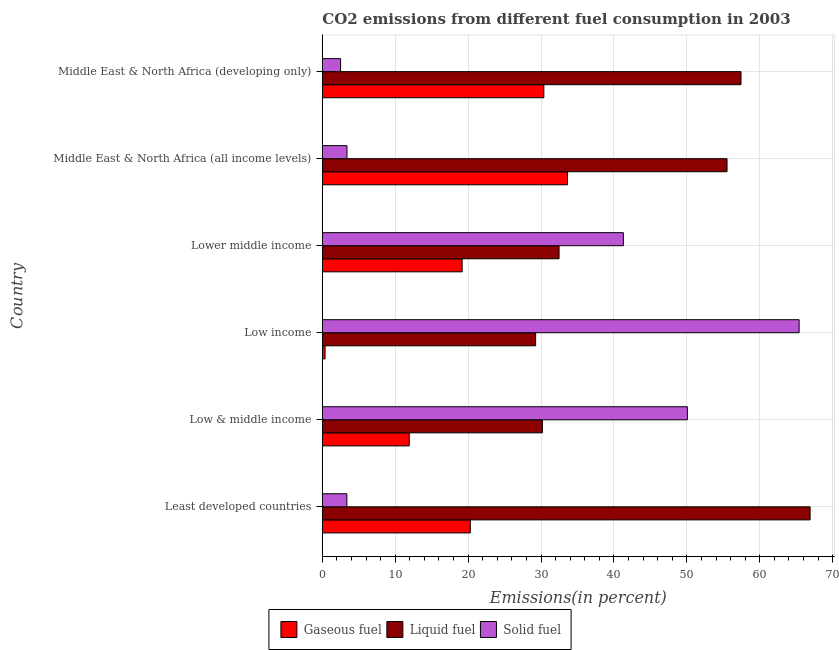How many groups of bars are there?
Make the answer very short. 6. Are the number of bars per tick equal to the number of legend labels?
Provide a succinct answer. Yes. How many bars are there on the 4th tick from the top?
Keep it short and to the point. 3. How many bars are there on the 4th tick from the bottom?
Provide a short and direct response. 3. What is the percentage of solid fuel emission in Middle East & North Africa (developing only)?
Provide a succinct answer. 2.5. Across all countries, what is the maximum percentage of liquid fuel emission?
Your answer should be very brief. 66.91. Across all countries, what is the minimum percentage of gaseous fuel emission?
Your answer should be compact. 0.38. In which country was the percentage of gaseous fuel emission minimum?
Offer a terse response. Low income. What is the total percentage of gaseous fuel emission in the graph?
Your answer should be compact. 115.78. What is the difference between the percentage of gaseous fuel emission in Low income and that in Lower middle income?
Make the answer very short. -18.8. What is the difference between the percentage of liquid fuel emission in Low & middle income and the percentage of gaseous fuel emission in Middle East & North Africa (developing only)?
Your answer should be compact. -0.2. What is the average percentage of gaseous fuel emission per country?
Your response must be concise. 19.3. What is the difference between the percentage of solid fuel emission and percentage of gaseous fuel emission in Middle East & North Africa (developing only)?
Provide a succinct answer. -27.88. In how many countries, is the percentage of liquid fuel emission greater than 58 %?
Provide a short and direct response. 1. What is the ratio of the percentage of liquid fuel emission in Least developed countries to that in Low & middle income?
Your answer should be compact. 2.22. Is the percentage of solid fuel emission in Least developed countries less than that in Middle East & North Africa (all income levels)?
Provide a short and direct response. Yes. Is the difference between the percentage of solid fuel emission in Low & middle income and Lower middle income greater than the difference between the percentage of liquid fuel emission in Low & middle income and Lower middle income?
Give a very brief answer. Yes. What is the difference between the highest and the second highest percentage of solid fuel emission?
Offer a terse response. 15.32. What is the difference between the highest and the lowest percentage of solid fuel emission?
Provide a succinct answer. 62.9. In how many countries, is the percentage of gaseous fuel emission greater than the average percentage of gaseous fuel emission taken over all countries?
Provide a succinct answer. 3. Is the sum of the percentage of gaseous fuel emission in Low & middle income and Low income greater than the maximum percentage of solid fuel emission across all countries?
Your answer should be compact. No. What does the 3rd bar from the top in Middle East & North Africa (all income levels) represents?
Keep it short and to the point. Gaseous fuel. What does the 2nd bar from the bottom in Lower middle income represents?
Offer a very short reply. Liquid fuel. Is it the case that in every country, the sum of the percentage of gaseous fuel emission and percentage of liquid fuel emission is greater than the percentage of solid fuel emission?
Provide a short and direct response. No. How many bars are there?
Make the answer very short. 18. Are the values on the major ticks of X-axis written in scientific E-notation?
Your response must be concise. No. Where does the legend appear in the graph?
Give a very brief answer. Bottom center. How many legend labels are there?
Your answer should be very brief. 3. How are the legend labels stacked?
Provide a succinct answer. Horizontal. What is the title of the graph?
Offer a very short reply. CO2 emissions from different fuel consumption in 2003. What is the label or title of the X-axis?
Your response must be concise. Emissions(in percent). What is the label or title of the Y-axis?
Offer a terse response. Country. What is the Emissions(in percent) of Gaseous fuel in Least developed countries?
Your answer should be very brief. 20.3. What is the Emissions(in percent) in Liquid fuel in Least developed countries?
Your response must be concise. 66.91. What is the Emissions(in percent) of Solid fuel in Least developed countries?
Offer a very short reply. 3.37. What is the Emissions(in percent) in Gaseous fuel in Low & middle income?
Make the answer very short. 11.92. What is the Emissions(in percent) of Liquid fuel in Low & middle income?
Provide a short and direct response. 30.19. What is the Emissions(in percent) of Solid fuel in Low & middle income?
Provide a short and direct response. 50.08. What is the Emissions(in percent) in Gaseous fuel in Low income?
Your answer should be compact. 0.38. What is the Emissions(in percent) of Liquid fuel in Low income?
Provide a short and direct response. 29.26. What is the Emissions(in percent) in Solid fuel in Low income?
Give a very brief answer. 65.4. What is the Emissions(in percent) of Gaseous fuel in Lower middle income?
Offer a terse response. 19.18. What is the Emissions(in percent) in Liquid fuel in Lower middle income?
Keep it short and to the point. 32.47. What is the Emissions(in percent) of Solid fuel in Lower middle income?
Give a very brief answer. 41.29. What is the Emissions(in percent) in Gaseous fuel in Middle East & North Africa (all income levels)?
Provide a short and direct response. 33.62. What is the Emissions(in percent) of Liquid fuel in Middle East & North Africa (all income levels)?
Your response must be concise. 55.51. What is the Emissions(in percent) of Solid fuel in Middle East & North Africa (all income levels)?
Offer a terse response. 3.38. What is the Emissions(in percent) of Gaseous fuel in Middle East & North Africa (developing only)?
Ensure brevity in your answer.  30.38. What is the Emissions(in percent) in Liquid fuel in Middle East & North Africa (developing only)?
Offer a terse response. 57.42. What is the Emissions(in percent) in Solid fuel in Middle East & North Africa (developing only)?
Ensure brevity in your answer.  2.5. Across all countries, what is the maximum Emissions(in percent) in Gaseous fuel?
Provide a succinct answer. 33.62. Across all countries, what is the maximum Emissions(in percent) in Liquid fuel?
Provide a succinct answer. 66.91. Across all countries, what is the maximum Emissions(in percent) of Solid fuel?
Provide a succinct answer. 65.4. Across all countries, what is the minimum Emissions(in percent) in Gaseous fuel?
Offer a terse response. 0.38. Across all countries, what is the minimum Emissions(in percent) in Liquid fuel?
Offer a very short reply. 29.26. Across all countries, what is the minimum Emissions(in percent) in Solid fuel?
Provide a short and direct response. 2.5. What is the total Emissions(in percent) of Gaseous fuel in the graph?
Make the answer very short. 115.78. What is the total Emissions(in percent) in Liquid fuel in the graph?
Your response must be concise. 271.76. What is the total Emissions(in percent) of Solid fuel in the graph?
Provide a short and direct response. 166.02. What is the difference between the Emissions(in percent) of Gaseous fuel in Least developed countries and that in Low & middle income?
Provide a short and direct response. 8.37. What is the difference between the Emissions(in percent) in Liquid fuel in Least developed countries and that in Low & middle income?
Offer a very short reply. 36.72. What is the difference between the Emissions(in percent) of Solid fuel in Least developed countries and that in Low & middle income?
Your answer should be compact. -46.71. What is the difference between the Emissions(in percent) of Gaseous fuel in Least developed countries and that in Low income?
Provide a succinct answer. 19.92. What is the difference between the Emissions(in percent) of Liquid fuel in Least developed countries and that in Low income?
Your answer should be compact. 37.65. What is the difference between the Emissions(in percent) of Solid fuel in Least developed countries and that in Low income?
Your answer should be compact. -62.03. What is the difference between the Emissions(in percent) of Gaseous fuel in Least developed countries and that in Lower middle income?
Provide a short and direct response. 1.12. What is the difference between the Emissions(in percent) in Liquid fuel in Least developed countries and that in Lower middle income?
Your answer should be compact. 34.43. What is the difference between the Emissions(in percent) in Solid fuel in Least developed countries and that in Lower middle income?
Offer a very short reply. -37.93. What is the difference between the Emissions(in percent) in Gaseous fuel in Least developed countries and that in Middle East & North Africa (all income levels)?
Give a very brief answer. -13.33. What is the difference between the Emissions(in percent) in Liquid fuel in Least developed countries and that in Middle East & North Africa (all income levels)?
Your response must be concise. 11.39. What is the difference between the Emissions(in percent) of Solid fuel in Least developed countries and that in Middle East & North Africa (all income levels)?
Your answer should be very brief. -0.01. What is the difference between the Emissions(in percent) in Gaseous fuel in Least developed countries and that in Middle East & North Africa (developing only)?
Provide a succinct answer. -10.09. What is the difference between the Emissions(in percent) in Liquid fuel in Least developed countries and that in Middle East & North Africa (developing only)?
Give a very brief answer. 9.48. What is the difference between the Emissions(in percent) in Solid fuel in Least developed countries and that in Middle East & North Africa (developing only)?
Provide a short and direct response. 0.86. What is the difference between the Emissions(in percent) of Gaseous fuel in Low & middle income and that in Low income?
Your response must be concise. 11.55. What is the difference between the Emissions(in percent) in Liquid fuel in Low & middle income and that in Low income?
Ensure brevity in your answer.  0.93. What is the difference between the Emissions(in percent) in Solid fuel in Low & middle income and that in Low income?
Your answer should be compact. -15.33. What is the difference between the Emissions(in percent) of Gaseous fuel in Low & middle income and that in Lower middle income?
Your response must be concise. -7.25. What is the difference between the Emissions(in percent) in Liquid fuel in Low & middle income and that in Lower middle income?
Keep it short and to the point. -2.29. What is the difference between the Emissions(in percent) in Solid fuel in Low & middle income and that in Lower middle income?
Ensure brevity in your answer.  8.78. What is the difference between the Emissions(in percent) in Gaseous fuel in Low & middle income and that in Middle East & North Africa (all income levels)?
Provide a succinct answer. -21.7. What is the difference between the Emissions(in percent) in Liquid fuel in Low & middle income and that in Middle East & North Africa (all income levels)?
Your response must be concise. -25.33. What is the difference between the Emissions(in percent) of Solid fuel in Low & middle income and that in Middle East & North Africa (all income levels)?
Provide a succinct answer. 46.7. What is the difference between the Emissions(in percent) of Gaseous fuel in Low & middle income and that in Middle East & North Africa (developing only)?
Make the answer very short. -18.46. What is the difference between the Emissions(in percent) in Liquid fuel in Low & middle income and that in Middle East & North Africa (developing only)?
Make the answer very short. -27.24. What is the difference between the Emissions(in percent) of Solid fuel in Low & middle income and that in Middle East & North Africa (developing only)?
Keep it short and to the point. 47.57. What is the difference between the Emissions(in percent) in Gaseous fuel in Low income and that in Lower middle income?
Your answer should be very brief. -18.8. What is the difference between the Emissions(in percent) of Liquid fuel in Low income and that in Lower middle income?
Offer a very short reply. -3.21. What is the difference between the Emissions(in percent) in Solid fuel in Low income and that in Lower middle income?
Offer a very short reply. 24.11. What is the difference between the Emissions(in percent) in Gaseous fuel in Low income and that in Middle East & North Africa (all income levels)?
Your answer should be compact. -33.25. What is the difference between the Emissions(in percent) of Liquid fuel in Low income and that in Middle East & North Africa (all income levels)?
Provide a succinct answer. -26.25. What is the difference between the Emissions(in percent) of Solid fuel in Low income and that in Middle East & North Africa (all income levels)?
Your answer should be very brief. 62.02. What is the difference between the Emissions(in percent) in Gaseous fuel in Low income and that in Middle East & North Africa (developing only)?
Offer a terse response. -30.01. What is the difference between the Emissions(in percent) of Liquid fuel in Low income and that in Middle East & North Africa (developing only)?
Provide a short and direct response. -28.17. What is the difference between the Emissions(in percent) of Solid fuel in Low income and that in Middle East & North Africa (developing only)?
Keep it short and to the point. 62.9. What is the difference between the Emissions(in percent) in Gaseous fuel in Lower middle income and that in Middle East & North Africa (all income levels)?
Offer a terse response. -14.45. What is the difference between the Emissions(in percent) of Liquid fuel in Lower middle income and that in Middle East & North Africa (all income levels)?
Provide a short and direct response. -23.04. What is the difference between the Emissions(in percent) of Solid fuel in Lower middle income and that in Middle East & North Africa (all income levels)?
Your response must be concise. 37.92. What is the difference between the Emissions(in percent) of Gaseous fuel in Lower middle income and that in Middle East & North Africa (developing only)?
Offer a terse response. -11.21. What is the difference between the Emissions(in percent) of Liquid fuel in Lower middle income and that in Middle East & North Africa (developing only)?
Make the answer very short. -24.95. What is the difference between the Emissions(in percent) of Solid fuel in Lower middle income and that in Middle East & North Africa (developing only)?
Your response must be concise. 38.79. What is the difference between the Emissions(in percent) of Gaseous fuel in Middle East & North Africa (all income levels) and that in Middle East & North Africa (developing only)?
Keep it short and to the point. 3.24. What is the difference between the Emissions(in percent) in Liquid fuel in Middle East & North Africa (all income levels) and that in Middle East & North Africa (developing only)?
Make the answer very short. -1.91. What is the difference between the Emissions(in percent) of Solid fuel in Middle East & North Africa (all income levels) and that in Middle East & North Africa (developing only)?
Provide a short and direct response. 0.87. What is the difference between the Emissions(in percent) of Gaseous fuel in Least developed countries and the Emissions(in percent) of Liquid fuel in Low & middle income?
Your answer should be very brief. -9.89. What is the difference between the Emissions(in percent) in Gaseous fuel in Least developed countries and the Emissions(in percent) in Solid fuel in Low & middle income?
Your answer should be very brief. -29.78. What is the difference between the Emissions(in percent) of Liquid fuel in Least developed countries and the Emissions(in percent) of Solid fuel in Low & middle income?
Your answer should be very brief. 16.83. What is the difference between the Emissions(in percent) in Gaseous fuel in Least developed countries and the Emissions(in percent) in Liquid fuel in Low income?
Offer a terse response. -8.96. What is the difference between the Emissions(in percent) of Gaseous fuel in Least developed countries and the Emissions(in percent) of Solid fuel in Low income?
Give a very brief answer. -45.1. What is the difference between the Emissions(in percent) of Liquid fuel in Least developed countries and the Emissions(in percent) of Solid fuel in Low income?
Ensure brevity in your answer.  1.51. What is the difference between the Emissions(in percent) in Gaseous fuel in Least developed countries and the Emissions(in percent) in Liquid fuel in Lower middle income?
Your response must be concise. -12.18. What is the difference between the Emissions(in percent) in Gaseous fuel in Least developed countries and the Emissions(in percent) in Solid fuel in Lower middle income?
Your answer should be compact. -21. What is the difference between the Emissions(in percent) in Liquid fuel in Least developed countries and the Emissions(in percent) in Solid fuel in Lower middle income?
Your answer should be compact. 25.61. What is the difference between the Emissions(in percent) of Gaseous fuel in Least developed countries and the Emissions(in percent) of Liquid fuel in Middle East & North Africa (all income levels)?
Offer a terse response. -35.22. What is the difference between the Emissions(in percent) of Gaseous fuel in Least developed countries and the Emissions(in percent) of Solid fuel in Middle East & North Africa (all income levels)?
Your answer should be very brief. 16.92. What is the difference between the Emissions(in percent) of Liquid fuel in Least developed countries and the Emissions(in percent) of Solid fuel in Middle East & North Africa (all income levels)?
Offer a terse response. 63.53. What is the difference between the Emissions(in percent) of Gaseous fuel in Least developed countries and the Emissions(in percent) of Liquid fuel in Middle East & North Africa (developing only)?
Give a very brief answer. -37.13. What is the difference between the Emissions(in percent) in Gaseous fuel in Least developed countries and the Emissions(in percent) in Solid fuel in Middle East & North Africa (developing only)?
Keep it short and to the point. 17.79. What is the difference between the Emissions(in percent) of Liquid fuel in Least developed countries and the Emissions(in percent) of Solid fuel in Middle East & North Africa (developing only)?
Make the answer very short. 64.4. What is the difference between the Emissions(in percent) in Gaseous fuel in Low & middle income and the Emissions(in percent) in Liquid fuel in Low income?
Provide a succinct answer. -17.33. What is the difference between the Emissions(in percent) in Gaseous fuel in Low & middle income and the Emissions(in percent) in Solid fuel in Low income?
Offer a terse response. -53.48. What is the difference between the Emissions(in percent) in Liquid fuel in Low & middle income and the Emissions(in percent) in Solid fuel in Low income?
Provide a succinct answer. -35.21. What is the difference between the Emissions(in percent) of Gaseous fuel in Low & middle income and the Emissions(in percent) of Liquid fuel in Lower middle income?
Offer a very short reply. -20.55. What is the difference between the Emissions(in percent) of Gaseous fuel in Low & middle income and the Emissions(in percent) of Solid fuel in Lower middle income?
Keep it short and to the point. -29.37. What is the difference between the Emissions(in percent) of Liquid fuel in Low & middle income and the Emissions(in percent) of Solid fuel in Lower middle income?
Ensure brevity in your answer.  -11.11. What is the difference between the Emissions(in percent) of Gaseous fuel in Low & middle income and the Emissions(in percent) of Liquid fuel in Middle East & North Africa (all income levels)?
Make the answer very short. -43.59. What is the difference between the Emissions(in percent) of Gaseous fuel in Low & middle income and the Emissions(in percent) of Solid fuel in Middle East & North Africa (all income levels)?
Provide a succinct answer. 8.55. What is the difference between the Emissions(in percent) in Liquid fuel in Low & middle income and the Emissions(in percent) in Solid fuel in Middle East & North Africa (all income levels)?
Provide a short and direct response. 26.81. What is the difference between the Emissions(in percent) in Gaseous fuel in Low & middle income and the Emissions(in percent) in Liquid fuel in Middle East & North Africa (developing only)?
Your answer should be compact. -45.5. What is the difference between the Emissions(in percent) in Gaseous fuel in Low & middle income and the Emissions(in percent) in Solid fuel in Middle East & North Africa (developing only)?
Provide a short and direct response. 9.42. What is the difference between the Emissions(in percent) of Liquid fuel in Low & middle income and the Emissions(in percent) of Solid fuel in Middle East & North Africa (developing only)?
Offer a very short reply. 27.68. What is the difference between the Emissions(in percent) of Gaseous fuel in Low income and the Emissions(in percent) of Liquid fuel in Lower middle income?
Your answer should be compact. -32.1. What is the difference between the Emissions(in percent) of Gaseous fuel in Low income and the Emissions(in percent) of Solid fuel in Lower middle income?
Make the answer very short. -40.92. What is the difference between the Emissions(in percent) of Liquid fuel in Low income and the Emissions(in percent) of Solid fuel in Lower middle income?
Your answer should be very brief. -12.04. What is the difference between the Emissions(in percent) in Gaseous fuel in Low income and the Emissions(in percent) in Liquid fuel in Middle East & North Africa (all income levels)?
Offer a very short reply. -55.14. What is the difference between the Emissions(in percent) of Gaseous fuel in Low income and the Emissions(in percent) of Solid fuel in Middle East & North Africa (all income levels)?
Provide a succinct answer. -3. What is the difference between the Emissions(in percent) in Liquid fuel in Low income and the Emissions(in percent) in Solid fuel in Middle East & North Africa (all income levels)?
Offer a terse response. 25.88. What is the difference between the Emissions(in percent) in Gaseous fuel in Low income and the Emissions(in percent) in Liquid fuel in Middle East & North Africa (developing only)?
Give a very brief answer. -57.05. What is the difference between the Emissions(in percent) of Gaseous fuel in Low income and the Emissions(in percent) of Solid fuel in Middle East & North Africa (developing only)?
Make the answer very short. -2.13. What is the difference between the Emissions(in percent) of Liquid fuel in Low income and the Emissions(in percent) of Solid fuel in Middle East & North Africa (developing only)?
Provide a short and direct response. 26.76. What is the difference between the Emissions(in percent) in Gaseous fuel in Lower middle income and the Emissions(in percent) in Liquid fuel in Middle East & North Africa (all income levels)?
Make the answer very short. -36.34. What is the difference between the Emissions(in percent) of Gaseous fuel in Lower middle income and the Emissions(in percent) of Solid fuel in Middle East & North Africa (all income levels)?
Provide a short and direct response. 15.8. What is the difference between the Emissions(in percent) of Liquid fuel in Lower middle income and the Emissions(in percent) of Solid fuel in Middle East & North Africa (all income levels)?
Provide a succinct answer. 29.09. What is the difference between the Emissions(in percent) of Gaseous fuel in Lower middle income and the Emissions(in percent) of Liquid fuel in Middle East & North Africa (developing only)?
Provide a short and direct response. -38.25. What is the difference between the Emissions(in percent) of Gaseous fuel in Lower middle income and the Emissions(in percent) of Solid fuel in Middle East & North Africa (developing only)?
Ensure brevity in your answer.  16.67. What is the difference between the Emissions(in percent) of Liquid fuel in Lower middle income and the Emissions(in percent) of Solid fuel in Middle East & North Africa (developing only)?
Make the answer very short. 29.97. What is the difference between the Emissions(in percent) in Gaseous fuel in Middle East & North Africa (all income levels) and the Emissions(in percent) in Liquid fuel in Middle East & North Africa (developing only)?
Your answer should be very brief. -23.8. What is the difference between the Emissions(in percent) of Gaseous fuel in Middle East & North Africa (all income levels) and the Emissions(in percent) of Solid fuel in Middle East & North Africa (developing only)?
Your answer should be very brief. 31.12. What is the difference between the Emissions(in percent) in Liquid fuel in Middle East & North Africa (all income levels) and the Emissions(in percent) in Solid fuel in Middle East & North Africa (developing only)?
Offer a very short reply. 53.01. What is the average Emissions(in percent) in Gaseous fuel per country?
Provide a short and direct response. 19.3. What is the average Emissions(in percent) in Liquid fuel per country?
Provide a succinct answer. 45.29. What is the average Emissions(in percent) of Solid fuel per country?
Provide a short and direct response. 27.67. What is the difference between the Emissions(in percent) of Gaseous fuel and Emissions(in percent) of Liquid fuel in Least developed countries?
Offer a very short reply. -46.61. What is the difference between the Emissions(in percent) of Gaseous fuel and Emissions(in percent) of Solid fuel in Least developed countries?
Your response must be concise. 16.93. What is the difference between the Emissions(in percent) of Liquid fuel and Emissions(in percent) of Solid fuel in Least developed countries?
Keep it short and to the point. 63.54. What is the difference between the Emissions(in percent) of Gaseous fuel and Emissions(in percent) of Liquid fuel in Low & middle income?
Provide a short and direct response. -18.26. What is the difference between the Emissions(in percent) in Gaseous fuel and Emissions(in percent) in Solid fuel in Low & middle income?
Your answer should be compact. -38.15. What is the difference between the Emissions(in percent) of Liquid fuel and Emissions(in percent) of Solid fuel in Low & middle income?
Ensure brevity in your answer.  -19.89. What is the difference between the Emissions(in percent) of Gaseous fuel and Emissions(in percent) of Liquid fuel in Low income?
Ensure brevity in your answer.  -28.88. What is the difference between the Emissions(in percent) in Gaseous fuel and Emissions(in percent) in Solid fuel in Low income?
Ensure brevity in your answer.  -65.02. What is the difference between the Emissions(in percent) in Liquid fuel and Emissions(in percent) in Solid fuel in Low income?
Ensure brevity in your answer.  -36.14. What is the difference between the Emissions(in percent) of Gaseous fuel and Emissions(in percent) of Liquid fuel in Lower middle income?
Provide a short and direct response. -13.3. What is the difference between the Emissions(in percent) of Gaseous fuel and Emissions(in percent) of Solid fuel in Lower middle income?
Offer a very short reply. -22.12. What is the difference between the Emissions(in percent) of Liquid fuel and Emissions(in percent) of Solid fuel in Lower middle income?
Provide a succinct answer. -8.82. What is the difference between the Emissions(in percent) in Gaseous fuel and Emissions(in percent) in Liquid fuel in Middle East & North Africa (all income levels)?
Your response must be concise. -21.89. What is the difference between the Emissions(in percent) in Gaseous fuel and Emissions(in percent) in Solid fuel in Middle East & North Africa (all income levels)?
Offer a very short reply. 30.25. What is the difference between the Emissions(in percent) in Liquid fuel and Emissions(in percent) in Solid fuel in Middle East & North Africa (all income levels)?
Give a very brief answer. 52.13. What is the difference between the Emissions(in percent) of Gaseous fuel and Emissions(in percent) of Liquid fuel in Middle East & North Africa (developing only)?
Make the answer very short. -27.04. What is the difference between the Emissions(in percent) in Gaseous fuel and Emissions(in percent) in Solid fuel in Middle East & North Africa (developing only)?
Provide a short and direct response. 27.88. What is the difference between the Emissions(in percent) of Liquid fuel and Emissions(in percent) of Solid fuel in Middle East & North Africa (developing only)?
Give a very brief answer. 54.92. What is the ratio of the Emissions(in percent) of Gaseous fuel in Least developed countries to that in Low & middle income?
Keep it short and to the point. 1.7. What is the ratio of the Emissions(in percent) of Liquid fuel in Least developed countries to that in Low & middle income?
Your response must be concise. 2.22. What is the ratio of the Emissions(in percent) in Solid fuel in Least developed countries to that in Low & middle income?
Your answer should be very brief. 0.07. What is the ratio of the Emissions(in percent) of Gaseous fuel in Least developed countries to that in Low income?
Ensure brevity in your answer.  53.97. What is the ratio of the Emissions(in percent) in Liquid fuel in Least developed countries to that in Low income?
Give a very brief answer. 2.29. What is the ratio of the Emissions(in percent) in Solid fuel in Least developed countries to that in Low income?
Keep it short and to the point. 0.05. What is the ratio of the Emissions(in percent) of Gaseous fuel in Least developed countries to that in Lower middle income?
Offer a terse response. 1.06. What is the ratio of the Emissions(in percent) of Liquid fuel in Least developed countries to that in Lower middle income?
Keep it short and to the point. 2.06. What is the ratio of the Emissions(in percent) of Solid fuel in Least developed countries to that in Lower middle income?
Keep it short and to the point. 0.08. What is the ratio of the Emissions(in percent) of Gaseous fuel in Least developed countries to that in Middle East & North Africa (all income levels)?
Provide a succinct answer. 0.6. What is the ratio of the Emissions(in percent) in Liquid fuel in Least developed countries to that in Middle East & North Africa (all income levels)?
Your response must be concise. 1.21. What is the ratio of the Emissions(in percent) in Gaseous fuel in Least developed countries to that in Middle East & North Africa (developing only)?
Ensure brevity in your answer.  0.67. What is the ratio of the Emissions(in percent) of Liquid fuel in Least developed countries to that in Middle East & North Africa (developing only)?
Your response must be concise. 1.17. What is the ratio of the Emissions(in percent) of Solid fuel in Least developed countries to that in Middle East & North Africa (developing only)?
Offer a terse response. 1.34. What is the ratio of the Emissions(in percent) in Gaseous fuel in Low & middle income to that in Low income?
Give a very brief answer. 31.71. What is the ratio of the Emissions(in percent) in Liquid fuel in Low & middle income to that in Low income?
Your answer should be very brief. 1.03. What is the ratio of the Emissions(in percent) in Solid fuel in Low & middle income to that in Low income?
Keep it short and to the point. 0.77. What is the ratio of the Emissions(in percent) in Gaseous fuel in Low & middle income to that in Lower middle income?
Your response must be concise. 0.62. What is the ratio of the Emissions(in percent) in Liquid fuel in Low & middle income to that in Lower middle income?
Offer a very short reply. 0.93. What is the ratio of the Emissions(in percent) of Solid fuel in Low & middle income to that in Lower middle income?
Provide a short and direct response. 1.21. What is the ratio of the Emissions(in percent) in Gaseous fuel in Low & middle income to that in Middle East & North Africa (all income levels)?
Give a very brief answer. 0.35. What is the ratio of the Emissions(in percent) of Liquid fuel in Low & middle income to that in Middle East & North Africa (all income levels)?
Provide a short and direct response. 0.54. What is the ratio of the Emissions(in percent) in Solid fuel in Low & middle income to that in Middle East & North Africa (all income levels)?
Your response must be concise. 14.83. What is the ratio of the Emissions(in percent) in Gaseous fuel in Low & middle income to that in Middle East & North Africa (developing only)?
Keep it short and to the point. 0.39. What is the ratio of the Emissions(in percent) of Liquid fuel in Low & middle income to that in Middle East & North Africa (developing only)?
Give a very brief answer. 0.53. What is the ratio of the Emissions(in percent) in Solid fuel in Low & middle income to that in Middle East & North Africa (developing only)?
Offer a terse response. 20. What is the ratio of the Emissions(in percent) of Gaseous fuel in Low income to that in Lower middle income?
Make the answer very short. 0.02. What is the ratio of the Emissions(in percent) of Liquid fuel in Low income to that in Lower middle income?
Your answer should be compact. 0.9. What is the ratio of the Emissions(in percent) in Solid fuel in Low income to that in Lower middle income?
Give a very brief answer. 1.58. What is the ratio of the Emissions(in percent) of Gaseous fuel in Low income to that in Middle East & North Africa (all income levels)?
Give a very brief answer. 0.01. What is the ratio of the Emissions(in percent) of Liquid fuel in Low income to that in Middle East & North Africa (all income levels)?
Give a very brief answer. 0.53. What is the ratio of the Emissions(in percent) of Solid fuel in Low income to that in Middle East & North Africa (all income levels)?
Keep it short and to the point. 19.36. What is the ratio of the Emissions(in percent) of Gaseous fuel in Low income to that in Middle East & North Africa (developing only)?
Provide a succinct answer. 0.01. What is the ratio of the Emissions(in percent) in Liquid fuel in Low income to that in Middle East & North Africa (developing only)?
Give a very brief answer. 0.51. What is the ratio of the Emissions(in percent) of Solid fuel in Low income to that in Middle East & North Africa (developing only)?
Make the answer very short. 26.13. What is the ratio of the Emissions(in percent) of Gaseous fuel in Lower middle income to that in Middle East & North Africa (all income levels)?
Your response must be concise. 0.57. What is the ratio of the Emissions(in percent) in Liquid fuel in Lower middle income to that in Middle East & North Africa (all income levels)?
Give a very brief answer. 0.58. What is the ratio of the Emissions(in percent) in Solid fuel in Lower middle income to that in Middle East & North Africa (all income levels)?
Give a very brief answer. 12.23. What is the ratio of the Emissions(in percent) of Gaseous fuel in Lower middle income to that in Middle East & North Africa (developing only)?
Provide a succinct answer. 0.63. What is the ratio of the Emissions(in percent) in Liquid fuel in Lower middle income to that in Middle East & North Africa (developing only)?
Make the answer very short. 0.57. What is the ratio of the Emissions(in percent) of Solid fuel in Lower middle income to that in Middle East & North Africa (developing only)?
Offer a terse response. 16.5. What is the ratio of the Emissions(in percent) in Gaseous fuel in Middle East & North Africa (all income levels) to that in Middle East & North Africa (developing only)?
Your response must be concise. 1.11. What is the ratio of the Emissions(in percent) in Liquid fuel in Middle East & North Africa (all income levels) to that in Middle East & North Africa (developing only)?
Give a very brief answer. 0.97. What is the ratio of the Emissions(in percent) in Solid fuel in Middle East & North Africa (all income levels) to that in Middle East & North Africa (developing only)?
Offer a very short reply. 1.35. What is the difference between the highest and the second highest Emissions(in percent) in Gaseous fuel?
Ensure brevity in your answer.  3.24. What is the difference between the highest and the second highest Emissions(in percent) in Liquid fuel?
Your response must be concise. 9.48. What is the difference between the highest and the second highest Emissions(in percent) in Solid fuel?
Give a very brief answer. 15.33. What is the difference between the highest and the lowest Emissions(in percent) in Gaseous fuel?
Provide a short and direct response. 33.25. What is the difference between the highest and the lowest Emissions(in percent) of Liquid fuel?
Provide a succinct answer. 37.65. What is the difference between the highest and the lowest Emissions(in percent) in Solid fuel?
Make the answer very short. 62.9. 